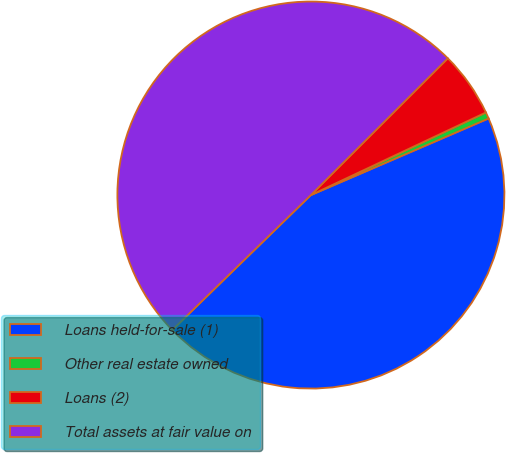<chart> <loc_0><loc_0><loc_500><loc_500><pie_chart><fcel>Loans held-for-sale (1)<fcel>Other real estate owned<fcel>Loans (2)<fcel>Total assets at fair value on<nl><fcel>44.19%<fcel>0.54%<fcel>5.47%<fcel>49.8%<nl></chart> 